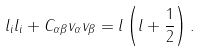Convert formula to latex. <formula><loc_0><loc_0><loc_500><loc_500>l _ { i } l _ { i } + C _ { \alpha \beta } v _ { \alpha } v _ { \beta } = l \left ( l + \frac { 1 } { 2 } \right ) .</formula> 